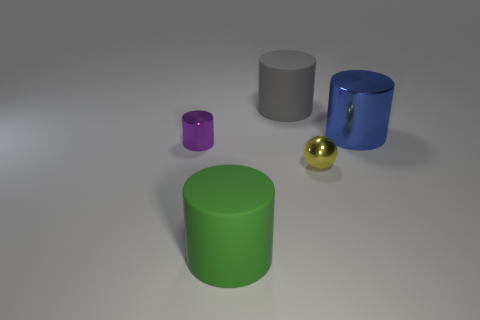Subtract 1 cylinders. How many cylinders are left? 3 Add 4 tiny blue matte cubes. How many objects exist? 9 Subtract all balls. How many objects are left? 4 Add 3 big blue things. How many big blue things are left? 4 Add 5 green rubber cylinders. How many green rubber cylinders exist? 6 Subtract 0 green spheres. How many objects are left? 5 Subtract all large matte things. Subtract all big gray rubber cylinders. How many objects are left? 2 